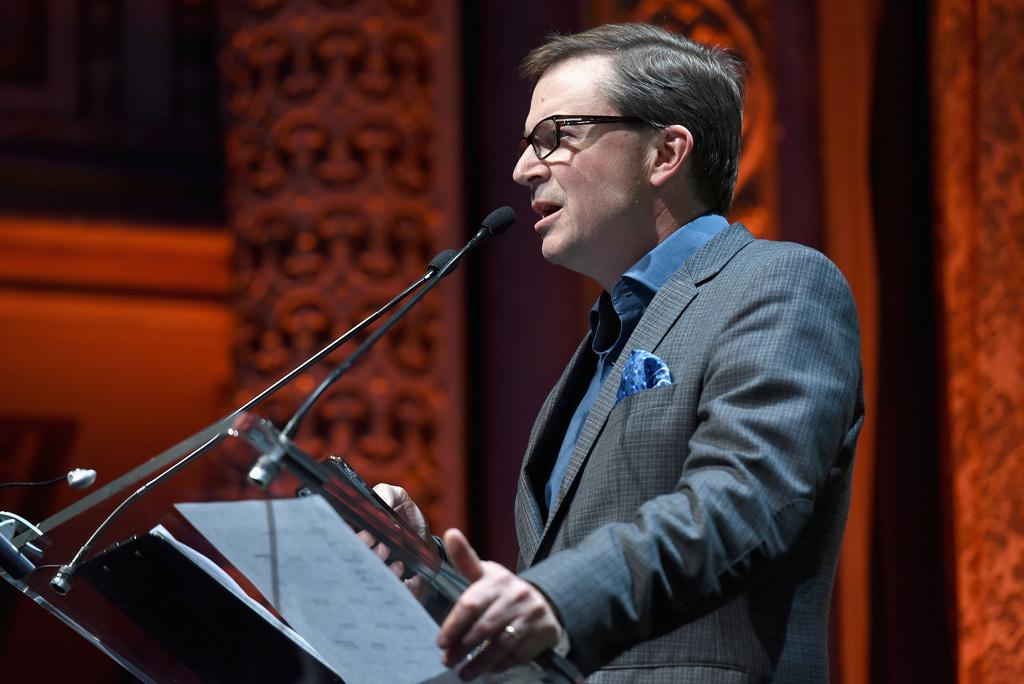What is the man in the image doing? The man is standing and speaking in the image. What is on the table in front of the man? There is a microphone and papers on the table in front of the man. Can you describe the table's location in relation to the man? The table is in front of the man. What is the condition of the background in the image? The background of the man is blurred. What type of star can be seen shining brightly in the image? There is no star visible in the image; it is focused on a man standing and speaking. What type of cloth is draped over the table in the image? There is no cloth draped over the table in the image; only a microphone and papers are present. 